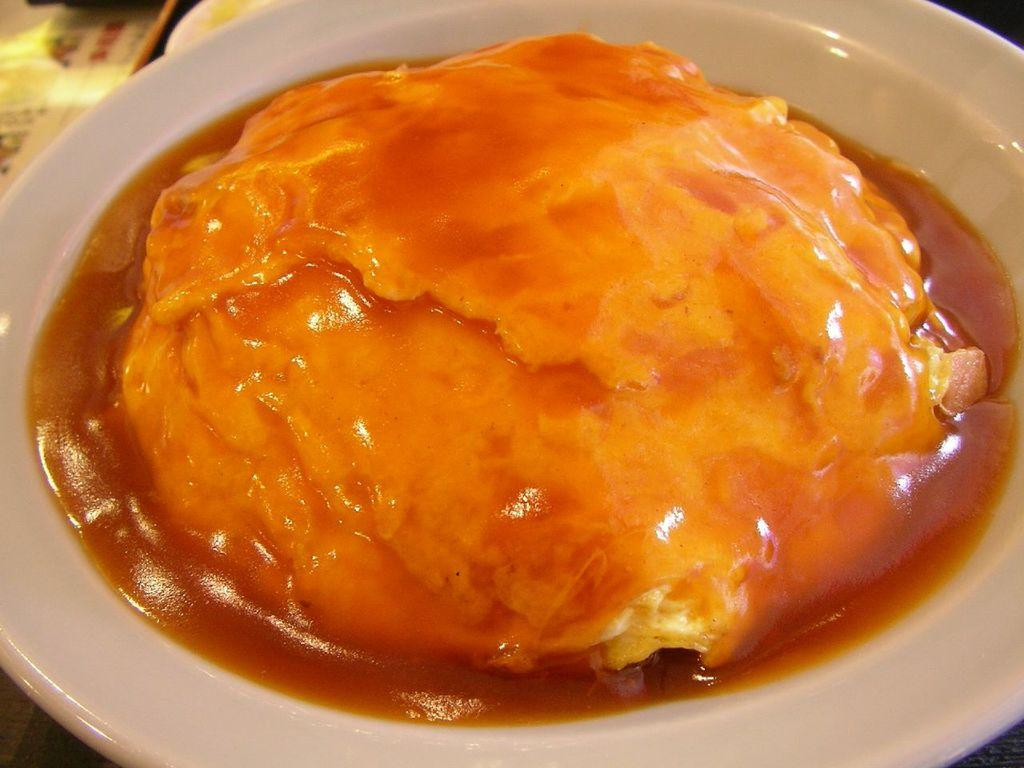What is the main subject of the image? There is a food item in the image. How is the food item presented in the image? The food item is served on a plate. How many kittens are sitting on the sofa in the image? There are no kittens or sofas present in the image; it only features a food item served on a plate. 